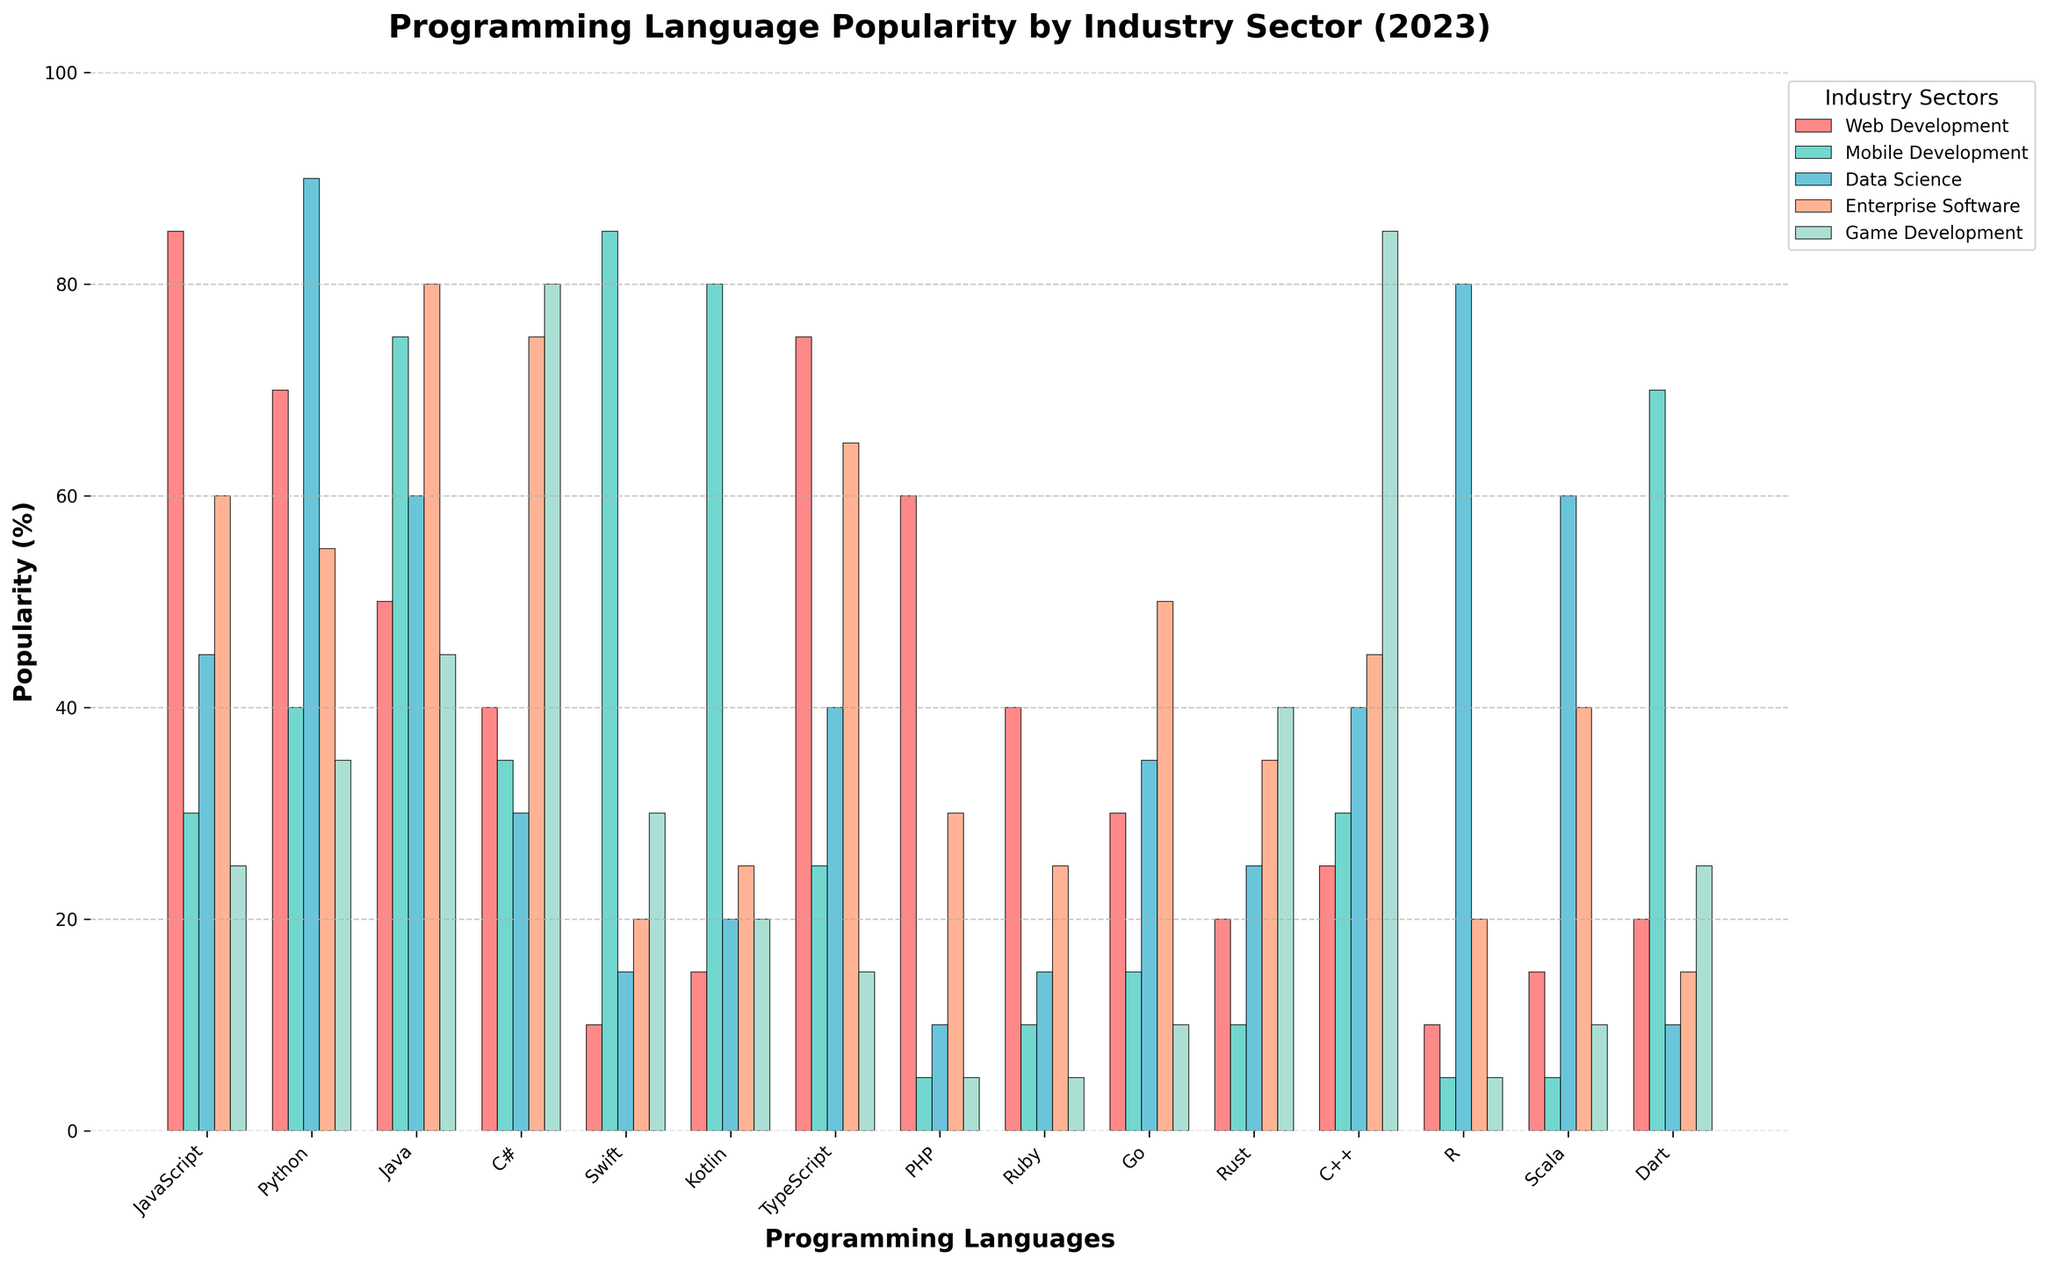Which programming language is most popular for Mobile Development? The tallest bar within the Mobile Development category indicates the most popular programming language for that sector. Swift has the highest value of 85%.
Answer: Swift Compare the popularity of Python in Data Science and Web Development. Which is higher? Look for the bars representing Python under both Data Science and Web Development and compare their heights. Python has a 90% popularity in Data Science and 70% in Web Development.
Answer: Data Science What is the combined popularity of Go in Enterprise Software and Game Development? Add the popularity percentages of Go in Enterprise Software (50%) and Game Development (10%). 50 + 10 = 60.
Answer: 60% Which sector has the least popularity of PHP? Find the shortest bar related to PHP across all industry sectors. The smallest value is 5% for Mobile Development and Game Development.
Answer: Mobile Development and Game Development Which industry sector shows the highest popularity for Java? Identify the tallest bar for Java across all industry sectors. Java has the highest popularity in Enterprise Software with 80%.
Answer: Enterprise Software Which programming language has a higher popularity in Game Development: Rust or C++? Compare the heights of the bars for Rust and C++ under Game Development. Rust has 40% and C++ has 85%.
Answer: C++ Calculate the average popularity of TypeScript across all industry sectors. Sum the popularity percentages of TypeScript in each sector: (75 + 25 + 40 + 65 + 15) = 220. Then divide by the number of sectors (5). 220 / 5 = 44.
Answer: 44% Is Python more popular in Web Development or Mobile Development? By how much? Compare the bars for Python in Web Development and Mobile Development. Python has 70% in Web Development and 40% in Mobile Development. The difference is 70 - 40 = 30.
Answer: Web Development, by 30% Which programming language shows a consistent popularity across the different sectors, and what is the range of its popularity? Look for a programming language with bars of similar height across sectors. JavaScript has values (85, 30, 45, 60, 25) - min is 25 and max is 85. The range is 85 - 25 = 60.
Answer: JavaScript, range is 60 What is the difference in popularity between JavaScript and TypeScript for Web Development? Subtract the popularity percentage of TypeScript from that of JavaScript for Web Development: 85 - 75 = 10.
Answer: 10% 